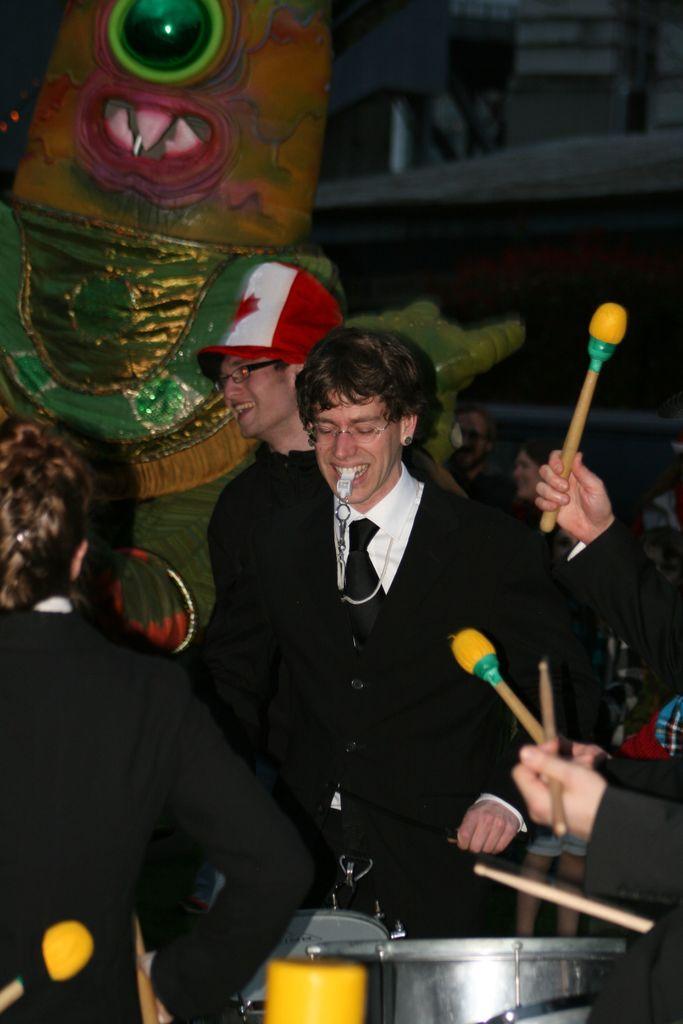Please provide a concise description of this image. In this image we can see a few people, among them some are holding the drumsticks, in front of them there are some drums, in the background we can see a sculpture and building. 